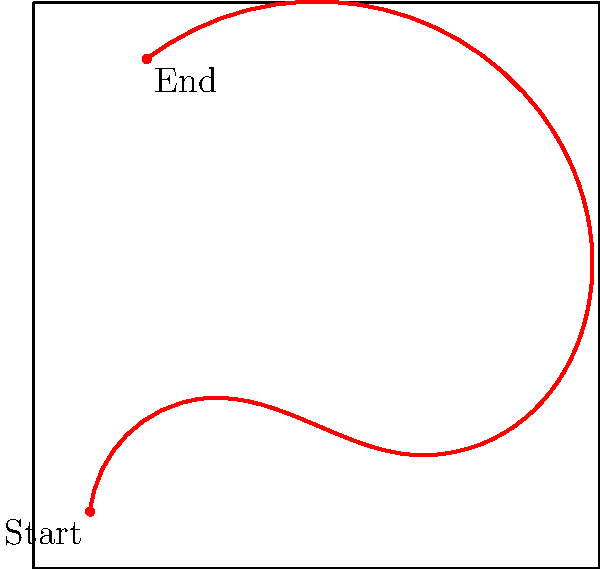As a police academy cadet, you're analyzing a building floor plan to estimate the perimeter of a winding escape route. The route starts at (10,10) and ends at (20,90) on a 100x100 meter grid. Given the path shown in red, estimate its perimeter to the nearest 10 meters. To estimate the perimeter of the winding escape route, we'll follow these steps:

1. Divide the path into approximate straight-line segments:
   - (10,10) to (30,30)
   - (30,30) to (70,20)
   - (70,20) to (90,80)
   - (90,80) to (20,90)

2. Estimate the length of each segment using the distance formula:
   $d = \sqrt{(x_2-x_1)^2 + (y_2-y_1)^2}$

   Segment 1: $\sqrt{(30-10)^2 + (30-10)^2} \approx 28.28$ m
   Segment 2: $\sqrt{(70-30)^2 + (20-30)^2} \approx 41.23$ m
   Segment 3: $\sqrt{(90-70)^2 + (80-20)^2} \approx 60.83$ m
   Segment 4: $\sqrt{(20-90)^2 + (90-80)^2} \approx 70.71$ m

3. Sum up the lengths:
   $28.28 + 41.23 + 60.83 + 70.71 = 201.05$ meters

4. Round to the nearest 10 meters:
   201.05 meters rounds to 200 meters

This estimation method accounts for the winding nature of the path while providing a reasonable approximation of its total length.
Answer: 200 meters 